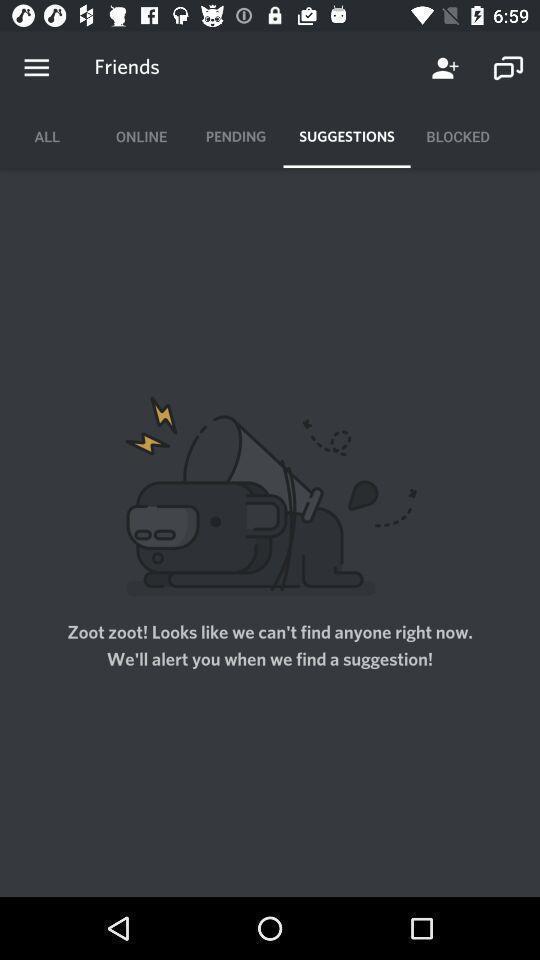Please provide a description for this image. Suggestions page. 